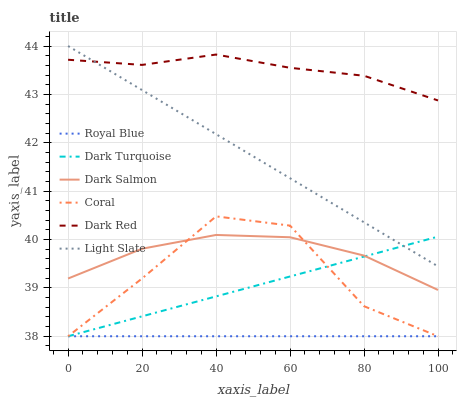Does Royal Blue have the minimum area under the curve?
Answer yes or no. Yes. Does Dark Red have the maximum area under the curve?
Answer yes or no. Yes. Does Coral have the minimum area under the curve?
Answer yes or no. No. Does Coral have the maximum area under the curve?
Answer yes or no. No. Is Royal Blue the smoothest?
Answer yes or no. Yes. Is Coral the roughest?
Answer yes or no. Yes. Is Dark Red the smoothest?
Answer yes or no. No. Is Dark Red the roughest?
Answer yes or no. No. Does Coral have the lowest value?
Answer yes or no. Yes. Does Dark Red have the lowest value?
Answer yes or no. No. Does Light Slate have the highest value?
Answer yes or no. Yes. Does Dark Red have the highest value?
Answer yes or no. No. Is Dark Salmon less than Light Slate?
Answer yes or no. Yes. Is Light Slate greater than Dark Salmon?
Answer yes or no. Yes. Does Dark Turquoise intersect Light Slate?
Answer yes or no. Yes. Is Dark Turquoise less than Light Slate?
Answer yes or no. No. Is Dark Turquoise greater than Light Slate?
Answer yes or no. No. Does Dark Salmon intersect Light Slate?
Answer yes or no. No. 